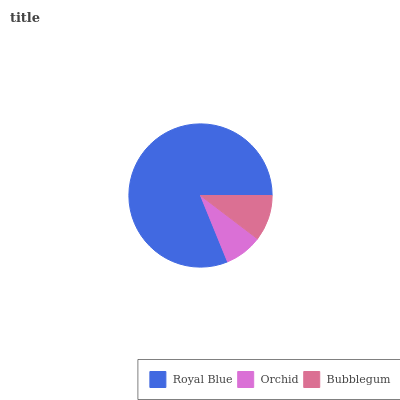Is Orchid the minimum?
Answer yes or no. Yes. Is Royal Blue the maximum?
Answer yes or no. Yes. Is Bubblegum the minimum?
Answer yes or no. No. Is Bubblegum the maximum?
Answer yes or no. No. Is Bubblegum greater than Orchid?
Answer yes or no. Yes. Is Orchid less than Bubblegum?
Answer yes or no. Yes. Is Orchid greater than Bubblegum?
Answer yes or no. No. Is Bubblegum less than Orchid?
Answer yes or no. No. Is Bubblegum the high median?
Answer yes or no. Yes. Is Bubblegum the low median?
Answer yes or no. Yes. Is Orchid the high median?
Answer yes or no. No. Is Orchid the low median?
Answer yes or no. No. 